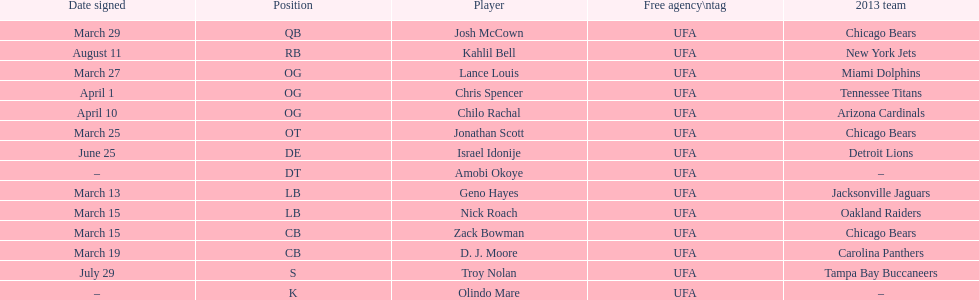How many players play cb or og? 5. Would you be able to parse every entry in this table? {'header': ['Date signed', 'Position', 'Player', 'Free agency\\ntag', '2013 team'], 'rows': [['March 29', 'QB', 'Josh McCown', 'UFA', 'Chicago Bears'], ['August 11', 'RB', 'Kahlil Bell', 'UFA', 'New York Jets'], ['March 27', 'OG', 'Lance Louis', 'UFA', 'Miami Dolphins'], ['April 1', 'OG', 'Chris Spencer', 'UFA', 'Tennessee Titans'], ['April 10', 'OG', 'Chilo Rachal', 'UFA', 'Arizona Cardinals'], ['March 25', 'OT', 'Jonathan Scott', 'UFA', 'Chicago Bears'], ['June 25', 'DE', 'Israel Idonije', 'UFA', 'Detroit Lions'], ['–', 'DT', 'Amobi Okoye', 'UFA', '–'], ['March 13', 'LB', 'Geno Hayes', 'UFA', 'Jacksonville Jaguars'], ['March 15', 'LB', 'Nick Roach', 'UFA', 'Oakland Raiders'], ['March 15', 'CB', 'Zack Bowman', 'UFA', 'Chicago Bears'], ['March 19', 'CB', 'D. J. Moore', 'UFA', 'Carolina Panthers'], ['July 29', 'S', 'Troy Nolan', 'UFA', 'Tampa Bay Buccaneers'], ['–', 'K', 'Olindo Mare', 'UFA', '–']]} 